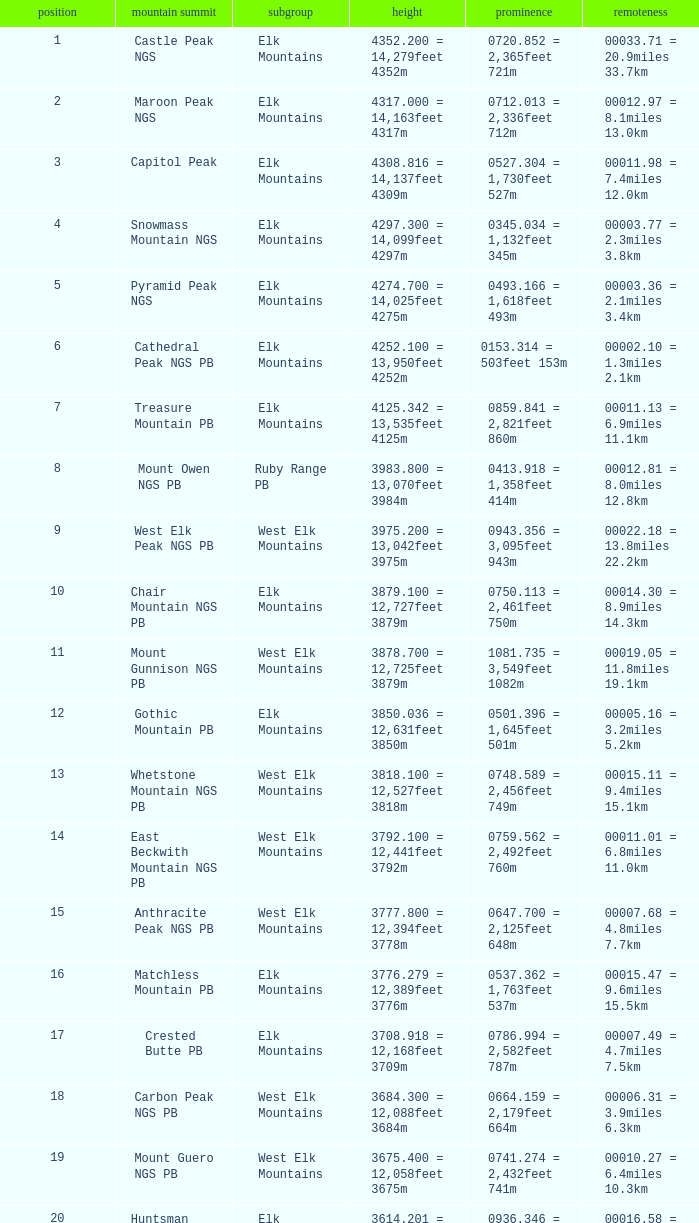Name the Rank of Rank Mountain Peak of crested butte pb? 17.0. 